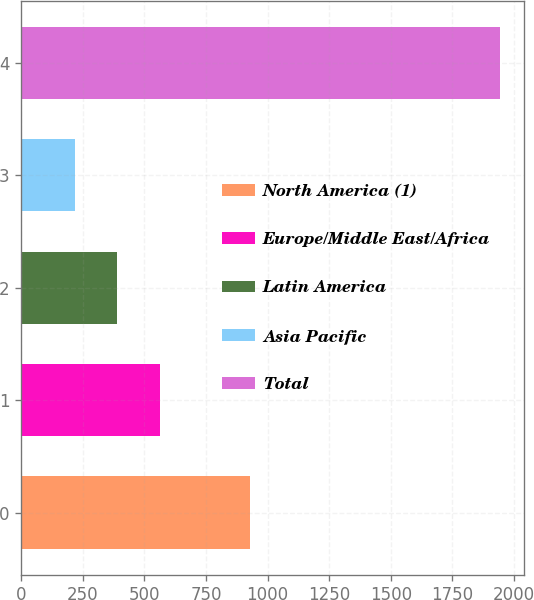Convert chart to OTSL. <chart><loc_0><loc_0><loc_500><loc_500><bar_chart><fcel>North America (1)<fcel>Europe/Middle East/Africa<fcel>Latin America<fcel>Asia Pacific<fcel>Total<nl><fcel>926.8<fcel>562.6<fcel>390.05<fcel>217.5<fcel>1943<nl></chart> 